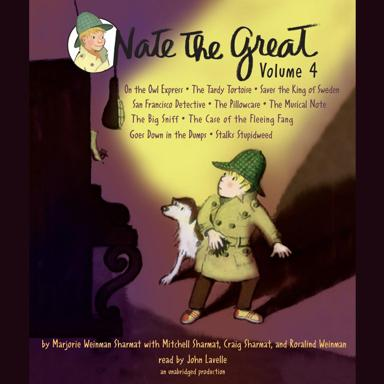What are some of the stories included in "The Great Volume 4"? 'Nate The Great Volume 4' includes intriguing titles such as "On the Owl Expre'", "The Tardy Tortoise Saves the King of Sweden," and "San Francisco Detective," among others. Each story brings a unique adventure, blending mystery with a touch of humor to captivate its audience. 